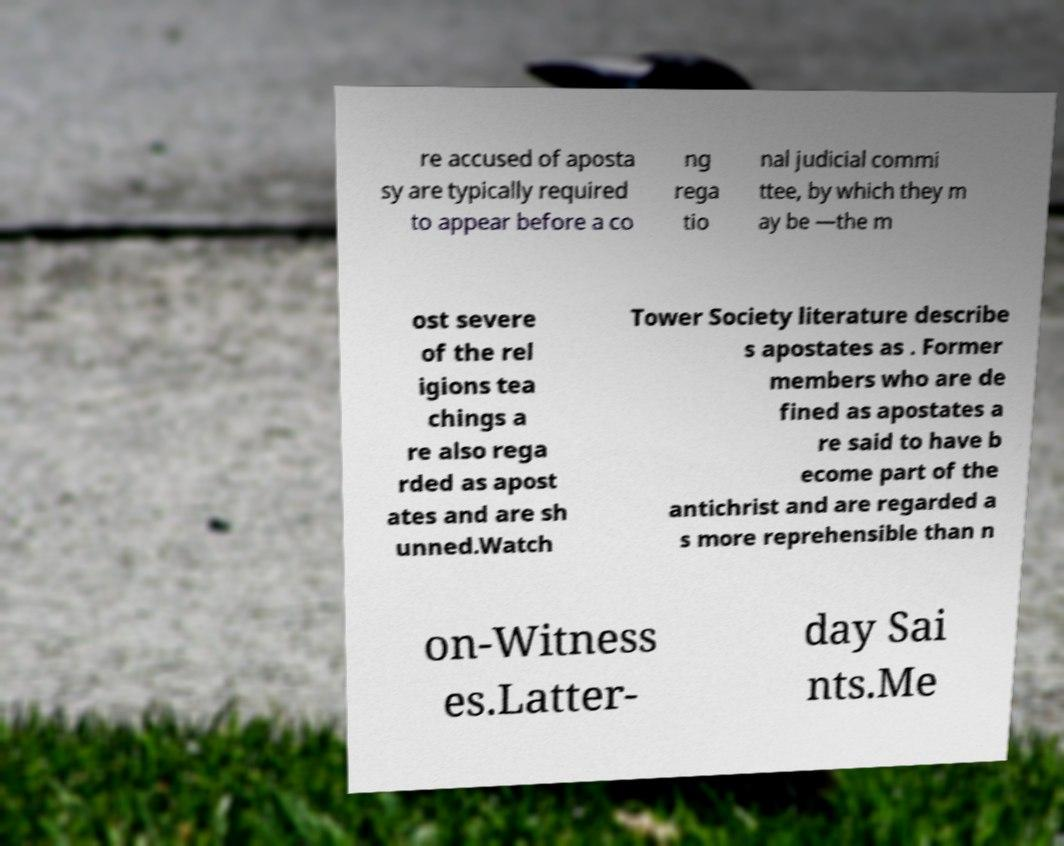What messages or text are displayed in this image? I need them in a readable, typed format. re accused of aposta sy are typically required to appear before a co ng rega tio nal judicial commi ttee, by which they m ay be —the m ost severe of the rel igions tea chings a re also rega rded as apost ates and are sh unned.Watch Tower Society literature describe s apostates as . Former members who are de fined as apostates a re said to have b ecome part of the antichrist and are regarded a s more reprehensible than n on-Witness es.Latter- day Sai nts.Me 